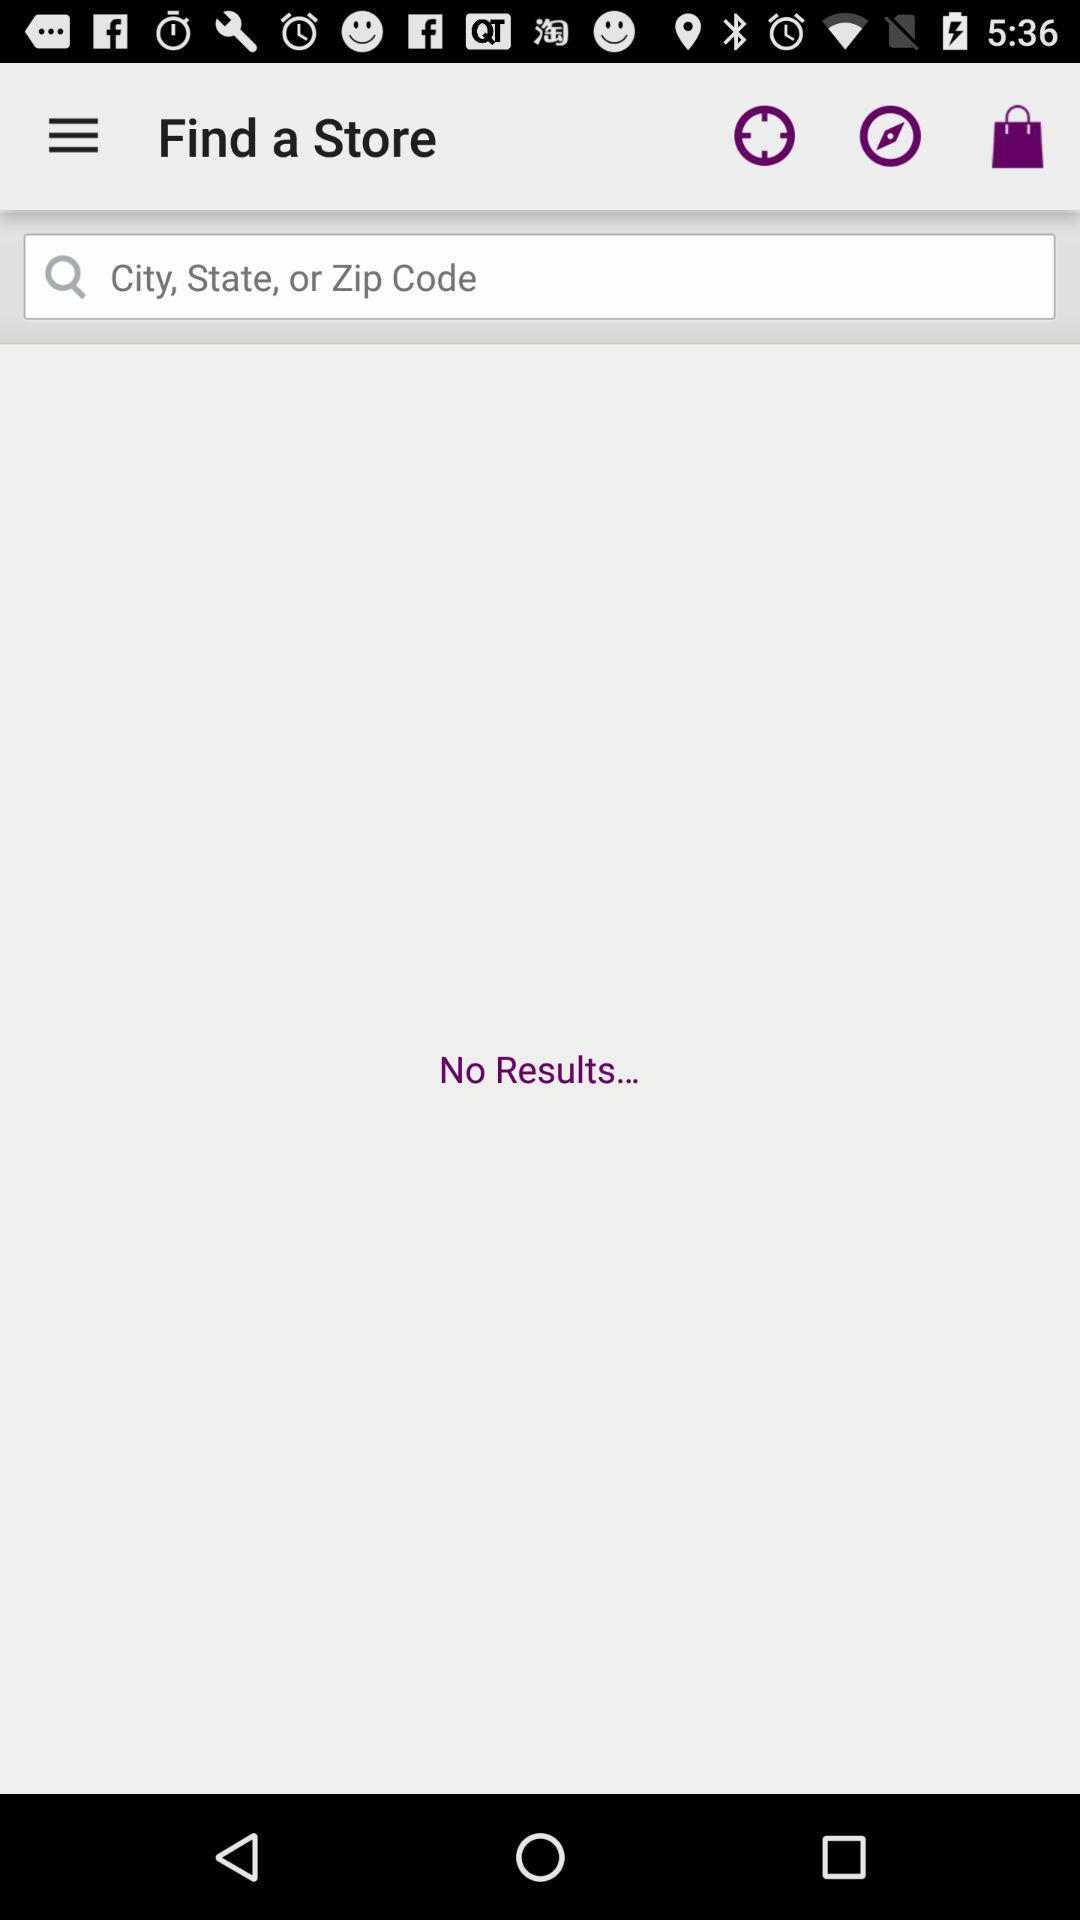Are there any results for a store? There are no results for a store. 